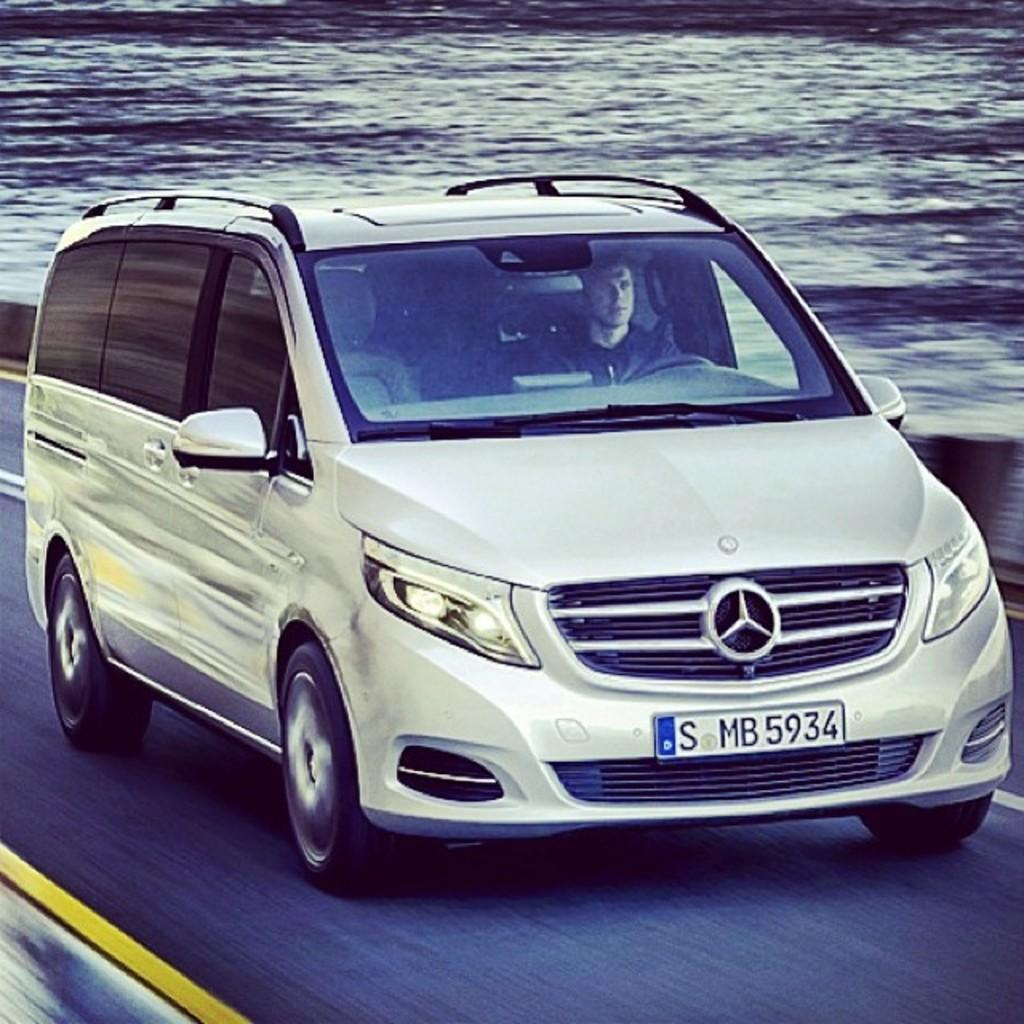<image>
Relay a brief, clear account of the picture shown. the Mercedes van has a license plate that says S MB 5934 